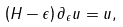<formula> <loc_0><loc_0><loc_500><loc_500>\left ( H - \epsilon \right ) \partial _ { \epsilon } u = u ,</formula> 